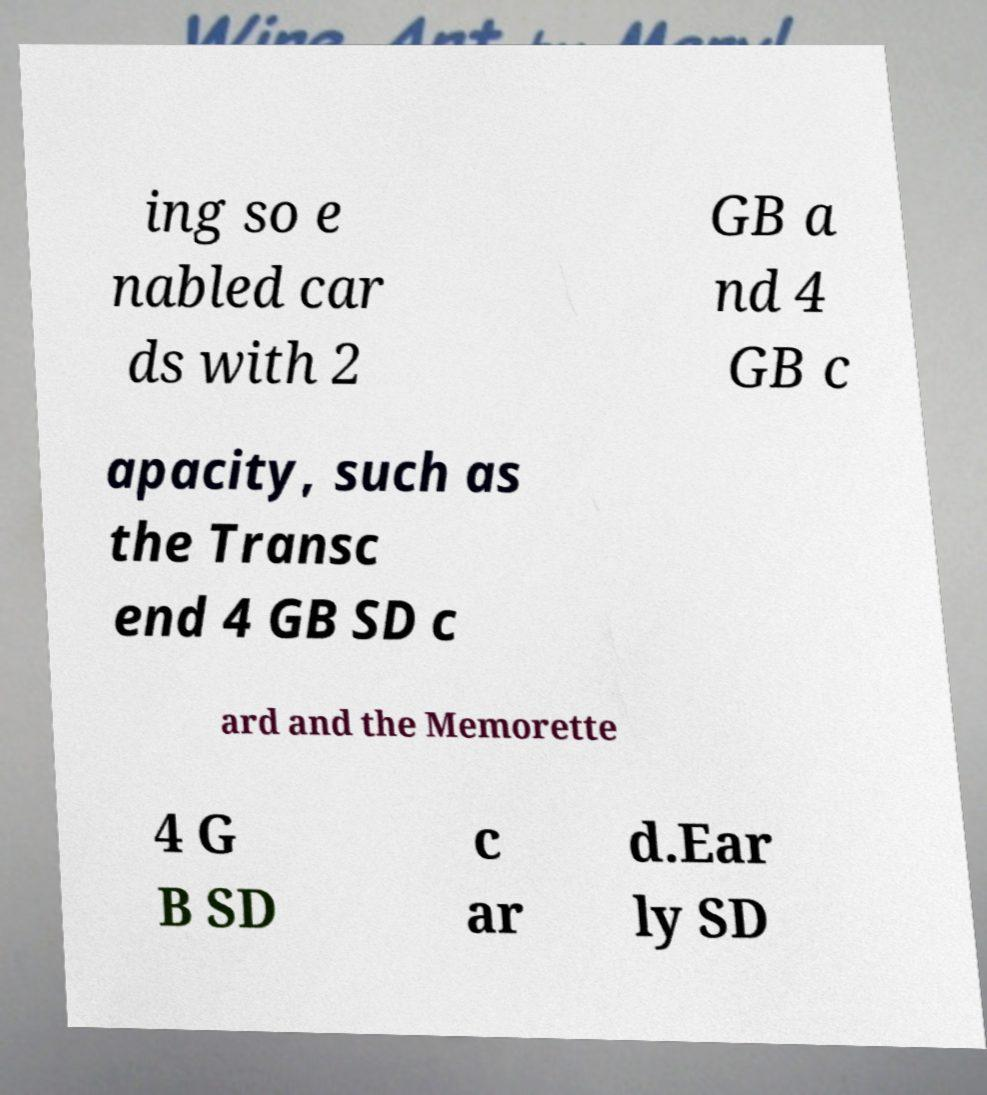Please read and relay the text visible in this image. What does it say? ing so e nabled car ds with 2 GB a nd 4 GB c apacity, such as the Transc end 4 GB SD c ard and the Memorette 4 G B SD c ar d.Ear ly SD 